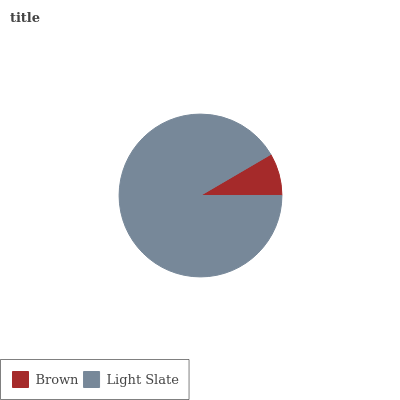Is Brown the minimum?
Answer yes or no. Yes. Is Light Slate the maximum?
Answer yes or no. Yes. Is Light Slate the minimum?
Answer yes or no. No. Is Light Slate greater than Brown?
Answer yes or no. Yes. Is Brown less than Light Slate?
Answer yes or no. Yes. Is Brown greater than Light Slate?
Answer yes or no. No. Is Light Slate less than Brown?
Answer yes or no. No. Is Light Slate the high median?
Answer yes or no. Yes. Is Brown the low median?
Answer yes or no. Yes. Is Brown the high median?
Answer yes or no. No. Is Light Slate the low median?
Answer yes or no. No. 